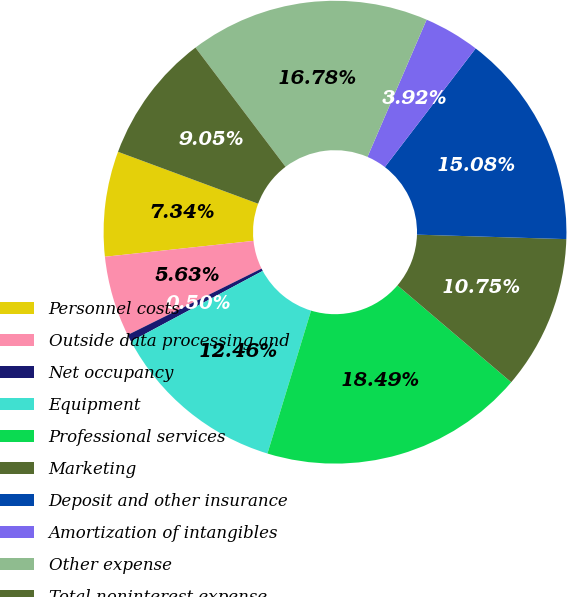Convert chart. <chart><loc_0><loc_0><loc_500><loc_500><pie_chart><fcel>Personnel costs<fcel>Outside data processing and<fcel>Net occupancy<fcel>Equipment<fcel>Professional services<fcel>Marketing<fcel>Deposit and other insurance<fcel>Amortization of intangibles<fcel>Other expense<fcel>Total noninterest expense<nl><fcel>7.34%<fcel>5.63%<fcel>0.5%<fcel>12.46%<fcel>18.49%<fcel>10.75%<fcel>15.08%<fcel>3.92%<fcel>16.78%<fcel>9.05%<nl></chart> 